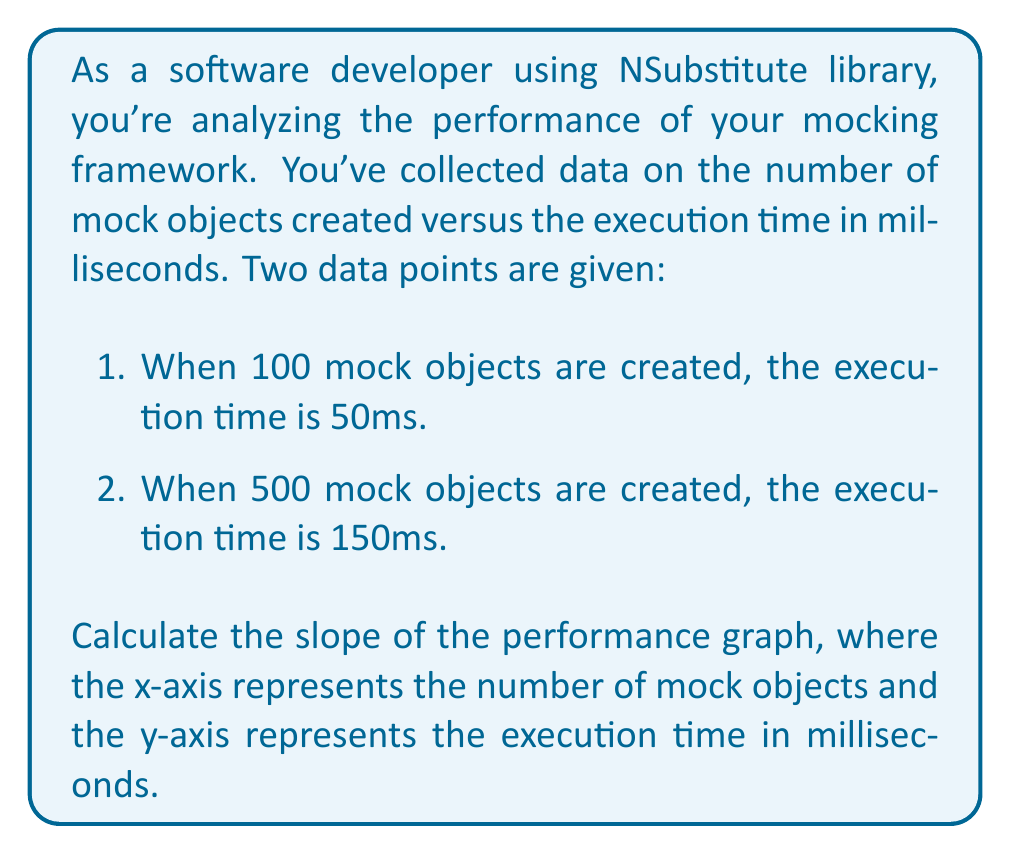Solve this math problem. To calculate the slope of the performance graph, we'll use the slope formula:

$$ \text{slope} = \frac{y_2 - y_1}{x_2 - x_1} $$

Where:
$(x_1, y_1)$ is the first point (100 mock objects, 50ms)
$(x_2, y_2)$ is the second point (500 mock objects, 150ms)

Let's plug in the values:

$$ \text{slope} = \frac{150 - 50}{500 - 100} $$

$$ = \frac{100}{400} $$

$$ = \frac{1}{4} = 0.25 $$

This slope represents the rate of change in execution time (in milliseconds) per additional mock object created.
Answer: The slope of the performance graph is $0.25$ ms/mock object. 